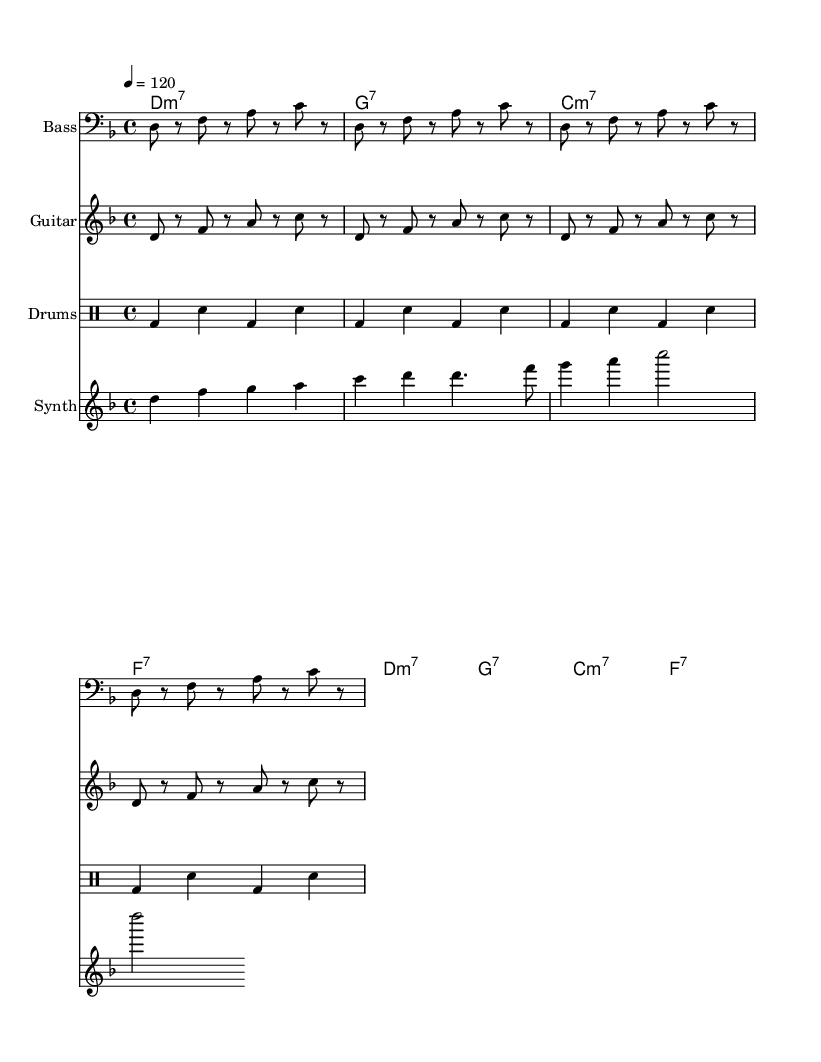What is the key signature of this music? The key signature is indicated by the one flat normally found at the beginning of the staff, which shows that the piece is in D minor.
Answer: D minor What is the time signature of this piece? The time signature is expressed as a fraction at the beginning of the score, which indicates there are four beats in each measure. The top number, "4", shows it is a quadruple meter and the bottom number, “4”, indicates that each beat is a quarter note.
Answer: 4/4 What is the tempo marking for this music? The tempo marking is shown in a specific format that includes a number followed by a equals sign. The indication of "4 = 120" specifies that the quarter note receives 120 beats per minute.
Answer: 120 How many measures are in the synth melody? By counting the distinct groups of notes separated by vertical lines (bar lines) in the synth melody section, a total of six measures are evident.
Answer: 6 What is the chord used in the first measure? The chord names written above the staff section indicate the chords played simultaneously; the first measure shows "D:m7" representing a D minor seventh chord.
Answer: D:m7 How many times is the bass line repeated? The repetition of the bass line is denoted by the instruction "repeat unfold 4" which indicates that the bass line sequence is played four times throughout the piece.
Answer: 4 What type of music is this composition categorized as? The characteristics of the rhythmic feel, instrumentation, and style presented in this composition align with the qualities of funk music, especially the groovy bass lines and syncopated rhythms.
Answer: Funk 